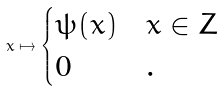<formula> <loc_0><loc_0><loc_500><loc_500>x \mapsto \begin{cases} \psi ( x ) & x \in Z \\ 0 & . \end{cases}</formula> 